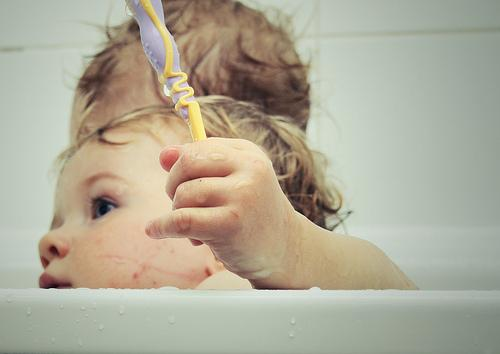What is the baby sitting holding? toothbrush 